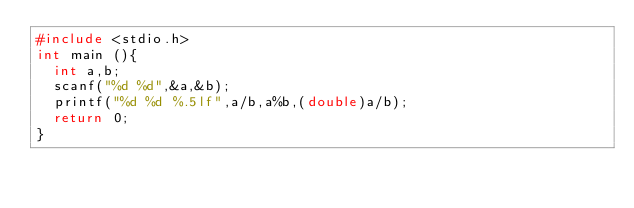Convert code to text. <code><loc_0><loc_0><loc_500><loc_500><_C_>#include <stdio.h>
int main (){
  int a,b;
  scanf("%d %d",&a,&b);
  printf("%d %d %.5lf",a/b,a%b,(double)a/b);
  return 0;
}
</code> 